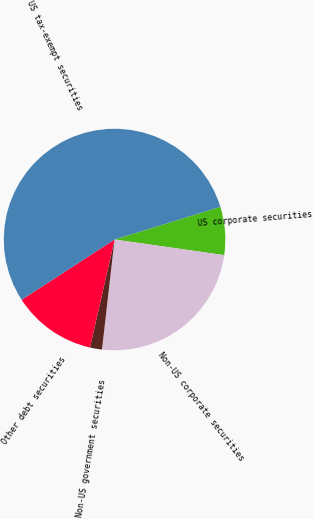<chart> <loc_0><loc_0><loc_500><loc_500><pie_chart><fcel>US corporate securities<fcel>Non-US corporate securities<fcel>Non-US government securities<fcel>Other debt securities<fcel>US tax-exempt securities<nl><fcel>7.02%<fcel>24.56%<fcel>1.75%<fcel>12.28%<fcel>54.39%<nl></chart> 